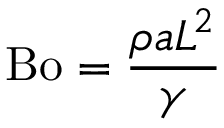<formula> <loc_0><loc_0><loc_500><loc_500>B o = { \frac { \rho a L ^ { 2 } } { \gamma } }</formula> 